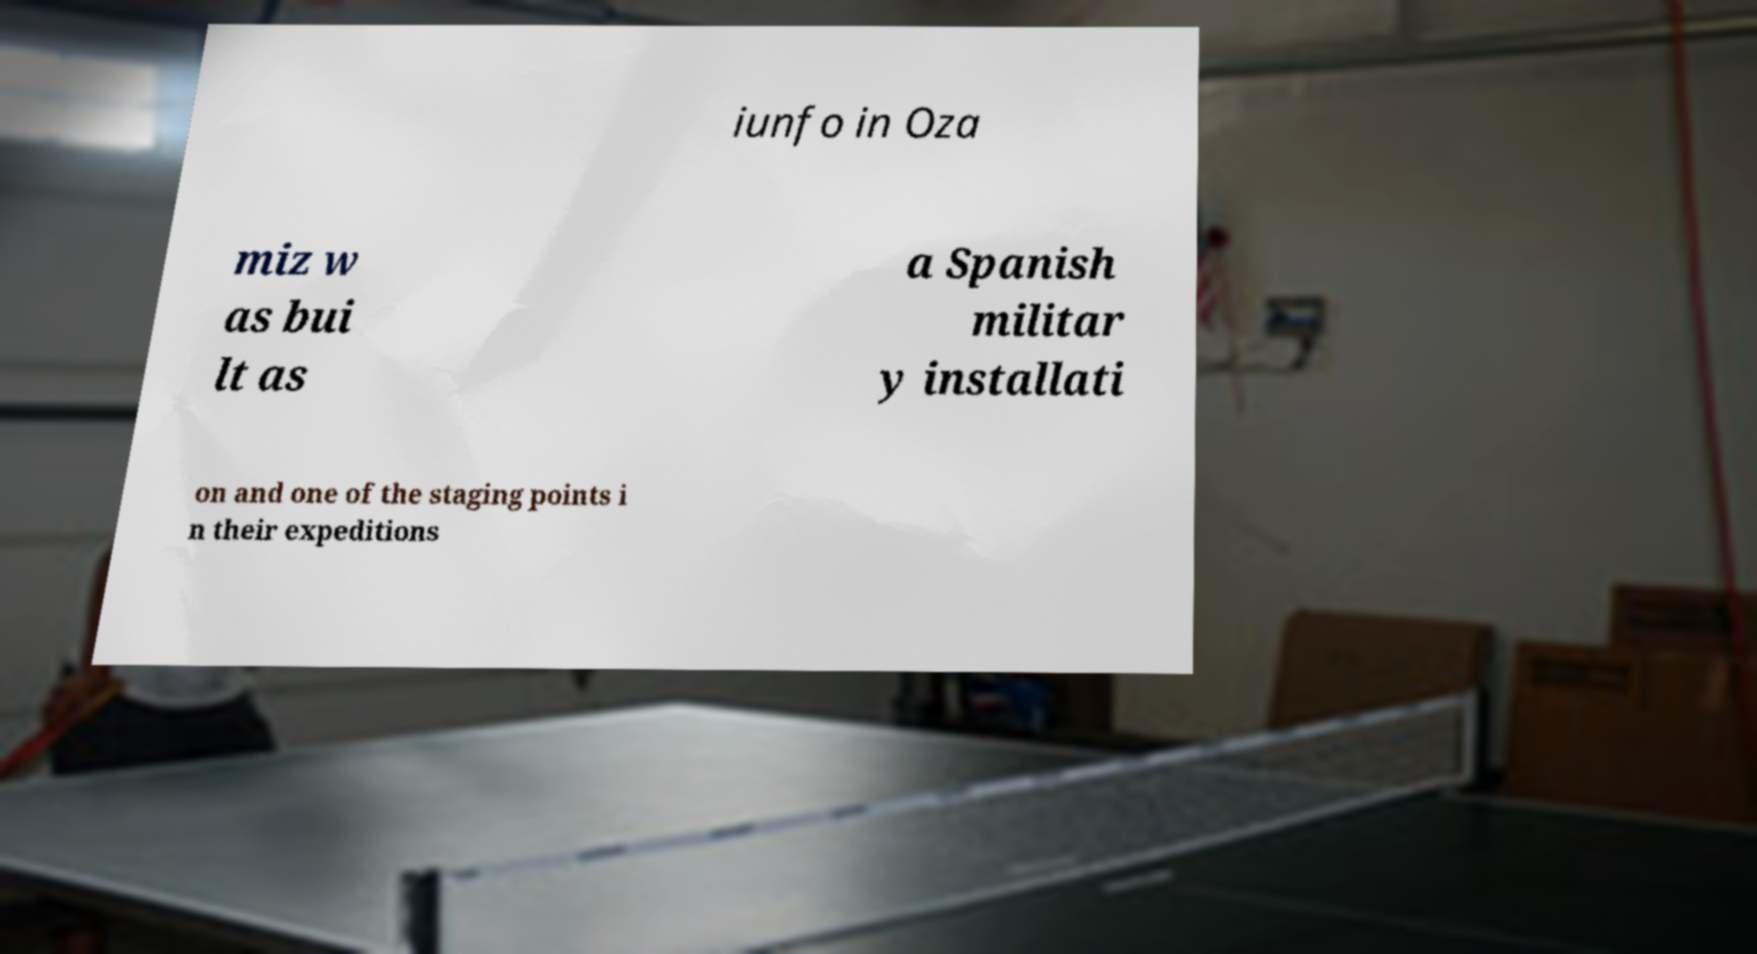Please identify and transcribe the text found in this image. iunfo in Oza miz w as bui lt as a Spanish militar y installati on and one of the staging points i n their expeditions 